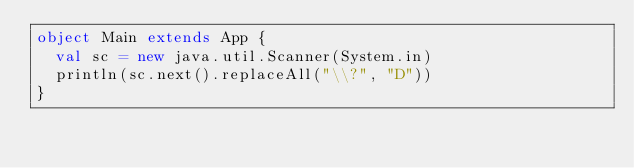Convert code to text. <code><loc_0><loc_0><loc_500><loc_500><_Scala_>object Main extends App {
  val sc = new java.util.Scanner(System.in)
  println(sc.next().replaceAll("\\?", "D"))
}
</code> 